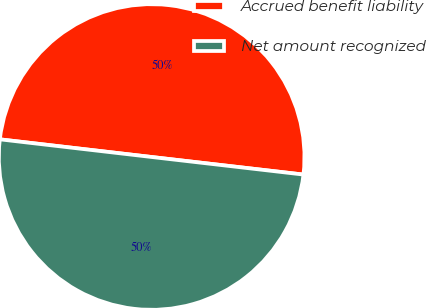Convert chart to OTSL. <chart><loc_0><loc_0><loc_500><loc_500><pie_chart><fcel>Accrued benefit liability<fcel>Net amount recognized<nl><fcel>49.99%<fcel>50.01%<nl></chart> 